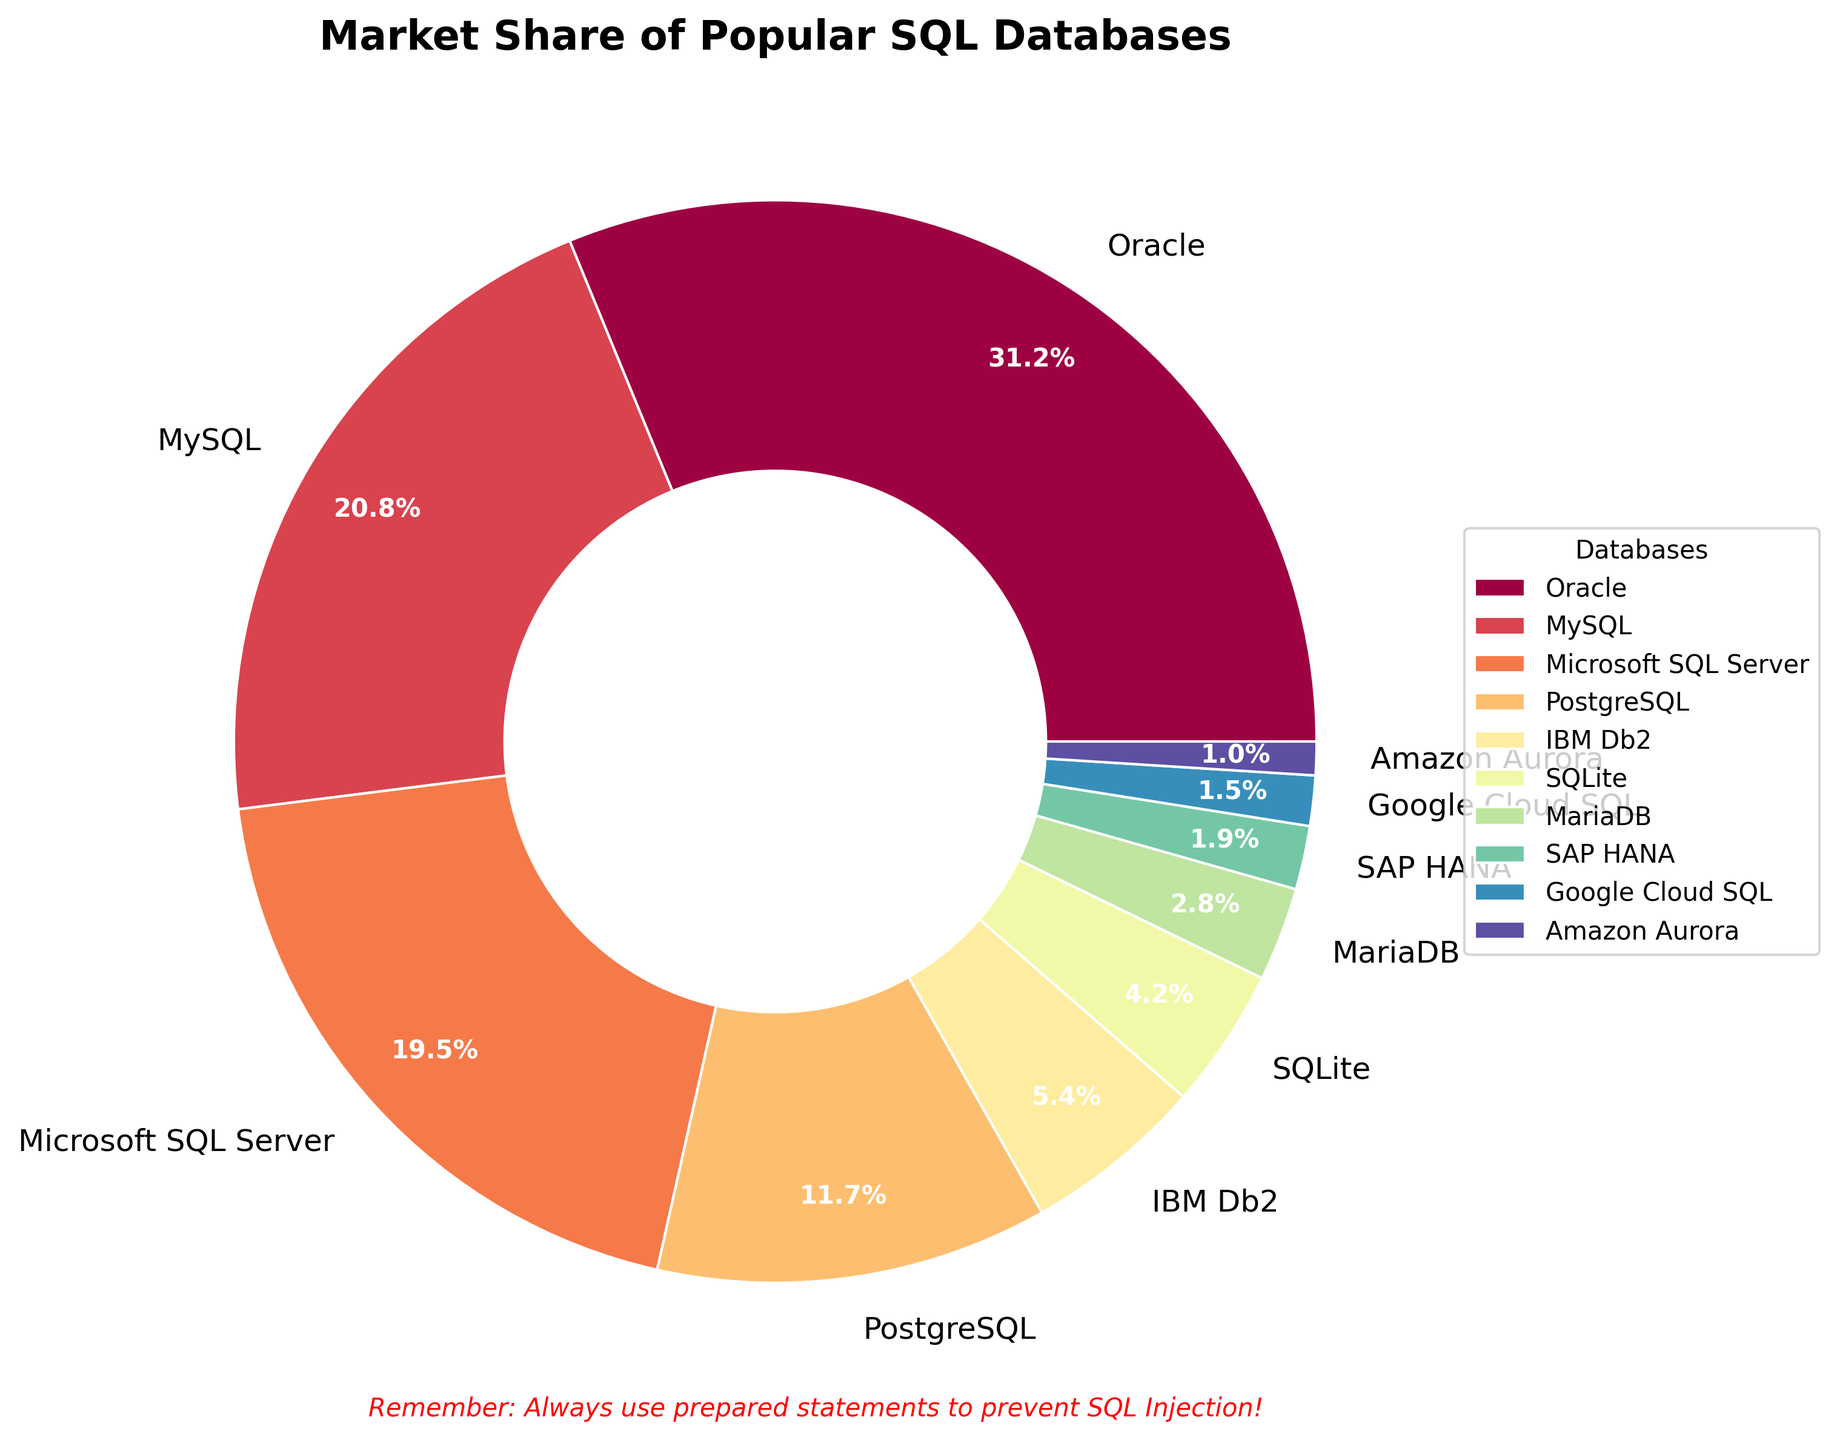What is the database with the highest market share? The pie chart clearly shows that Oracle has the largest segment, which represents its market share of 31.2%.
Answer: Oracle Which two databases have a collective market share greater than 50%? Oracle and MySQL together have a market share of 31.2% and 20.8% respectively. Adding these values gives 52%, which is greater than 50%.
Answer: Oracle and MySQL Compare the market share of PostgreSQL to SQLite, which one has a higher market share? The pie chart shows PostgreSQL with a market share of 11.7% and SQLite with a market share of 4.2%. By comparing these two numbers, we can see that PostgreSQL has a higher market share.
Answer: PostgreSQL What is the total market share of databases with less than 5% each? Adding the market shares of IBM Db2 (5.4%), SQLite (4.2%), MariaDB (2.8%), SAP HANA (1.9%), Google Cloud SQL (1.5%), and Amazon Aurora (1.0%) results in a total of 16.8%.
Answer: 16.8% Which database has a segment colored closest to red in the spectrum? The segment coloring follows a gradient from the spectral color map. Oracle's segment, being the largest and typically given the most prominent color, appears closest to red.
Answer: Oracle What is the market share difference between Oracle and Microsoft SQL Server? Oracle has a market share of 31.2% while Microsoft SQL Server has 19.5%. The difference is calculated as 31.2% - 19.5% = 11.7%.
Answer: 11.7% How does the market share of SAP HANA compare to Amazon Aurora? The market share of SAP HANA is 1.9% and Amazon Aurora is 1.0%. SAP HANA's market share is almost twice that of Amazon Aurora.
Answer: SAP HANA has a higher market share What is the average market share of MySQL, Oracle, and PostgreSQL? To find the average, sum the market shares of MySQL (20.8%), Oracle (31.2%), and PostgreSQL (11.7%) which equals 63.7%, and divide by the number of databases (3). The resulting average market share is 63.7% / 3 = 21.23%.
Answer: 21.23% Which database has the smallest market share and what is it? The database with the smallest segment on the pie chart is Amazon Aurora with a market share of 1.0%.
Answer: Amazon Aurora, 1.0% What is the combined market share of the top three databases? The top three databases are Oracle, MySQL, and Microsoft SQL Server. Their market shares are 31.2%, 20.8%, and 19.5% respectively. Adding these values gives a total market share of 71.5%.
Answer: 71.5% 